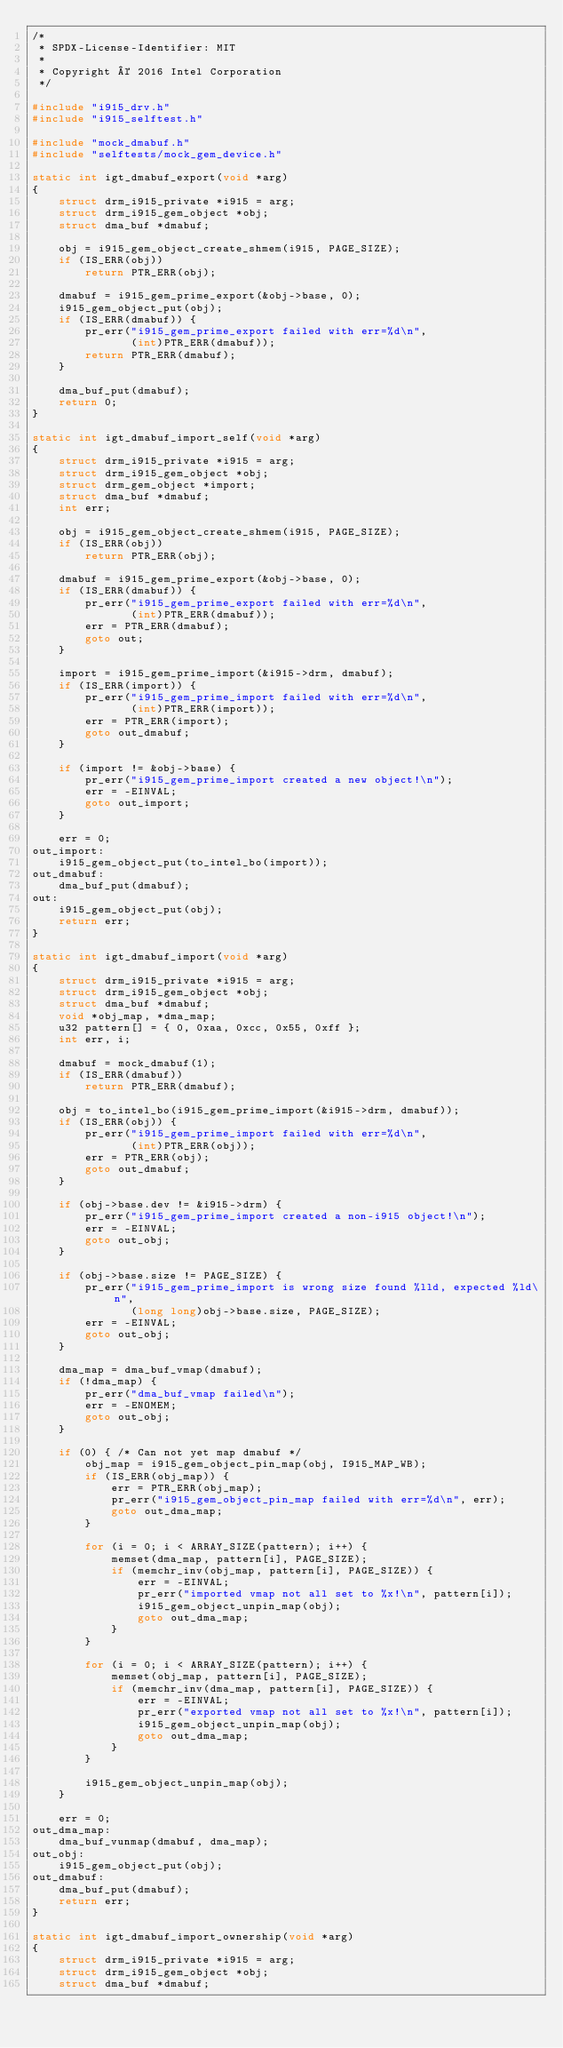<code> <loc_0><loc_0><loc_500><loc_500><_C_>/*
 * SPDX-License-Identifier: MIT
 *
 * Copyright © 2016 Intel Corporation
 */

#include "i915_drv.h"
#include "i915_selftest.h"

#include "mock_dmabuf.h"
#include "selftests/mock_gem_device.h"

static int igt_dmabuf_export(void *arg)
{
	struct drm_i915_private *i915 = arg;
	struct drm_i915_gem_object *obj;
	struct dma_buf *dmabuf;

	obj = i915_gem_object_create_shmem(i915, PAGE_SIZE);
	if (IS_ERR(obj))
		return PTR_ERR(obj);

	dmabuf = i915_gem_prime_export(&obj->base, 0);
	i915_gem_object_put(obj);
	if (IS_ERR(dmabuf)) {
		pr_err("i915_gem_prime_export failed with err=%d\n",
		       (int)PTR_ERR(dmabuf));
		return PTR_ERR(dmabuf);
	}

	dma_buf_put(dmabuf);
	return 0;
}

static int igt_dmabuf_import_self(void *arg)
{
	struct drm_i915_private *i915 = arg;
	struct drm_i915_gem_object *obj;
	struct drm_gem_object *import;
	struct dma_buf *dmabuf;
	int err;

	obj = i915_gem_object_create_shmem(i915, PAGE_SIZE);
	if (IS_ERR(obj))
		return PTR_ERR(obj);

	dmabuf = i915_gem_prime_export(&obj->base, 0);
	if (IS_ERR(dmabuf)) {
		pr_err("i915_gem_prime_export failed with err=%d\n",
		       (int)PTR_ERR(dmabuf));
		err = PTR_ERR(dmabuf);
		goto out;
	}

	import = i915_gem_prime_import(&i915->drm, dmabuf);
	if (IS_ERR(import)) {
		pr_err("i915_gem_prime_import failed with err=%d\n",
		       (int)PTR_ERR(import));
		err = PTR_ERR(import);
		goto out_dmabuf;
	}

	if (import != &obj->base) {
		pr_err("i915_gem_prime_import created a new object!\n");
		err = -EINVAL;
		goto out_import;
	}

	err = 0;
out_import:
	i915_gem_object_put(to_intel_bo(import));
out_dmabuf:
	dma_buf_put(dmabuf);
out:
	i915_gem_object_put(obj);
	return err;
}

static int igt_dmabuf_import(void *arg)
{
	struct drm_i915_private *i915 = arg;
	struct drm_i915_gem_object *obj;
	struct dma_buf *dmabuf;
	void *obj_map, *dma_map;
	u32 pattern[] = { 0, 0xaa, 0xcc, 0x55, 0xff };
	int err, i;

	dmabuf = mock_dmabuf(1);
	if (IS_ERR(dmabuf))
		return PTR_ERR(dmabuf);

	obj = to_intel_bo(i915_gem_prime_import(&i915->drm, dmabuf));
	if (IS_ERR(obj)) {
		pr_err("i915_gem_prime_import failed with err=%d\n",
		       (int)PTR_ERR(obj));
		err = PTR_ERR(obj);
		goto out_dmabuf;
	}

	if (obj->base.dev != &i915->drm) {
		pr_err("i915_gem_prime_import created a non-i915 object!\n");
		err = -EINVAL;
		goto out_obj;
	}

	if (obj->base.size != PAGE_SIZE) {
		pr_err("i915_gem_prime_import is wrong size found %lld, expected %ld\n",
		       (long long)obj->base.size, PAGE_SIZE);
		err = -EINVAL;
		goto out_obj;
	}

	dma_map = dma_buf_vmap(dmabuf);
	if (!dma_map) {
		pr_err("dma_buf_vmap failed\n");
		err = -ENOMEM;
		goto out_obj;
	}

	if (0) { /* Can not yet map dmabuf */
		obj_map = i915_gem_object_pin_map(obj, I915_MAP_WB);
		if (IS_ERR(obj_map)) {
			err = PTR_ERR(obj_map);
			pr_err("i915_gem_object_pin_map failed with err=%d\n", err);
			goto out_dma_map;
		}

		for (i = 0; i < ARRAY_SIZE(pattern); i++) {
			memset(dma_map, pattern[i], PAGE_SIZE);
			if (memchr_inv(obj_map, pattern[i], PAGE_SIZE)) {
				err = -EINVAL;
				pr_err("imported vmap not all set to %x!\n", pattern[i]);
				i915_gem_object_unpin_map(obj);
				goto out_dma_map;
			}
		}

		for (i = 0; i < ARRAY_SIZE(pattern); i++) {
			memset(obj_map, pattern[i], PAGE_SIZE);
			if (memchr_inv(dma_map, pattern[i], PAGE_SIZE)) {
				err = -EINVAL;
				pr_err("exported vmap not all set to %x!\n", pattern[i]);
				i915_gem_object_unpin_map(obj);
				goto out_dma_map;
			}
		}

		i915_gem_object_unpin_map(obj);
	}

	err = 0;
out_dma_map:
	dma_buf_vunmap(dmabuf, dma_map);
out_obj:
	i915_gem_object_put(obj);
out_dmabuf:
	dma_buf_put(dmabuf);
	return err;
}

static int igt_dmabuf_import_ownership(void *arg)
{
	struct drm_i915_private *i915 = arg;
	struct drm_i915_gem_object *obj;
	struct dma_buf *dmabuf;</code> 